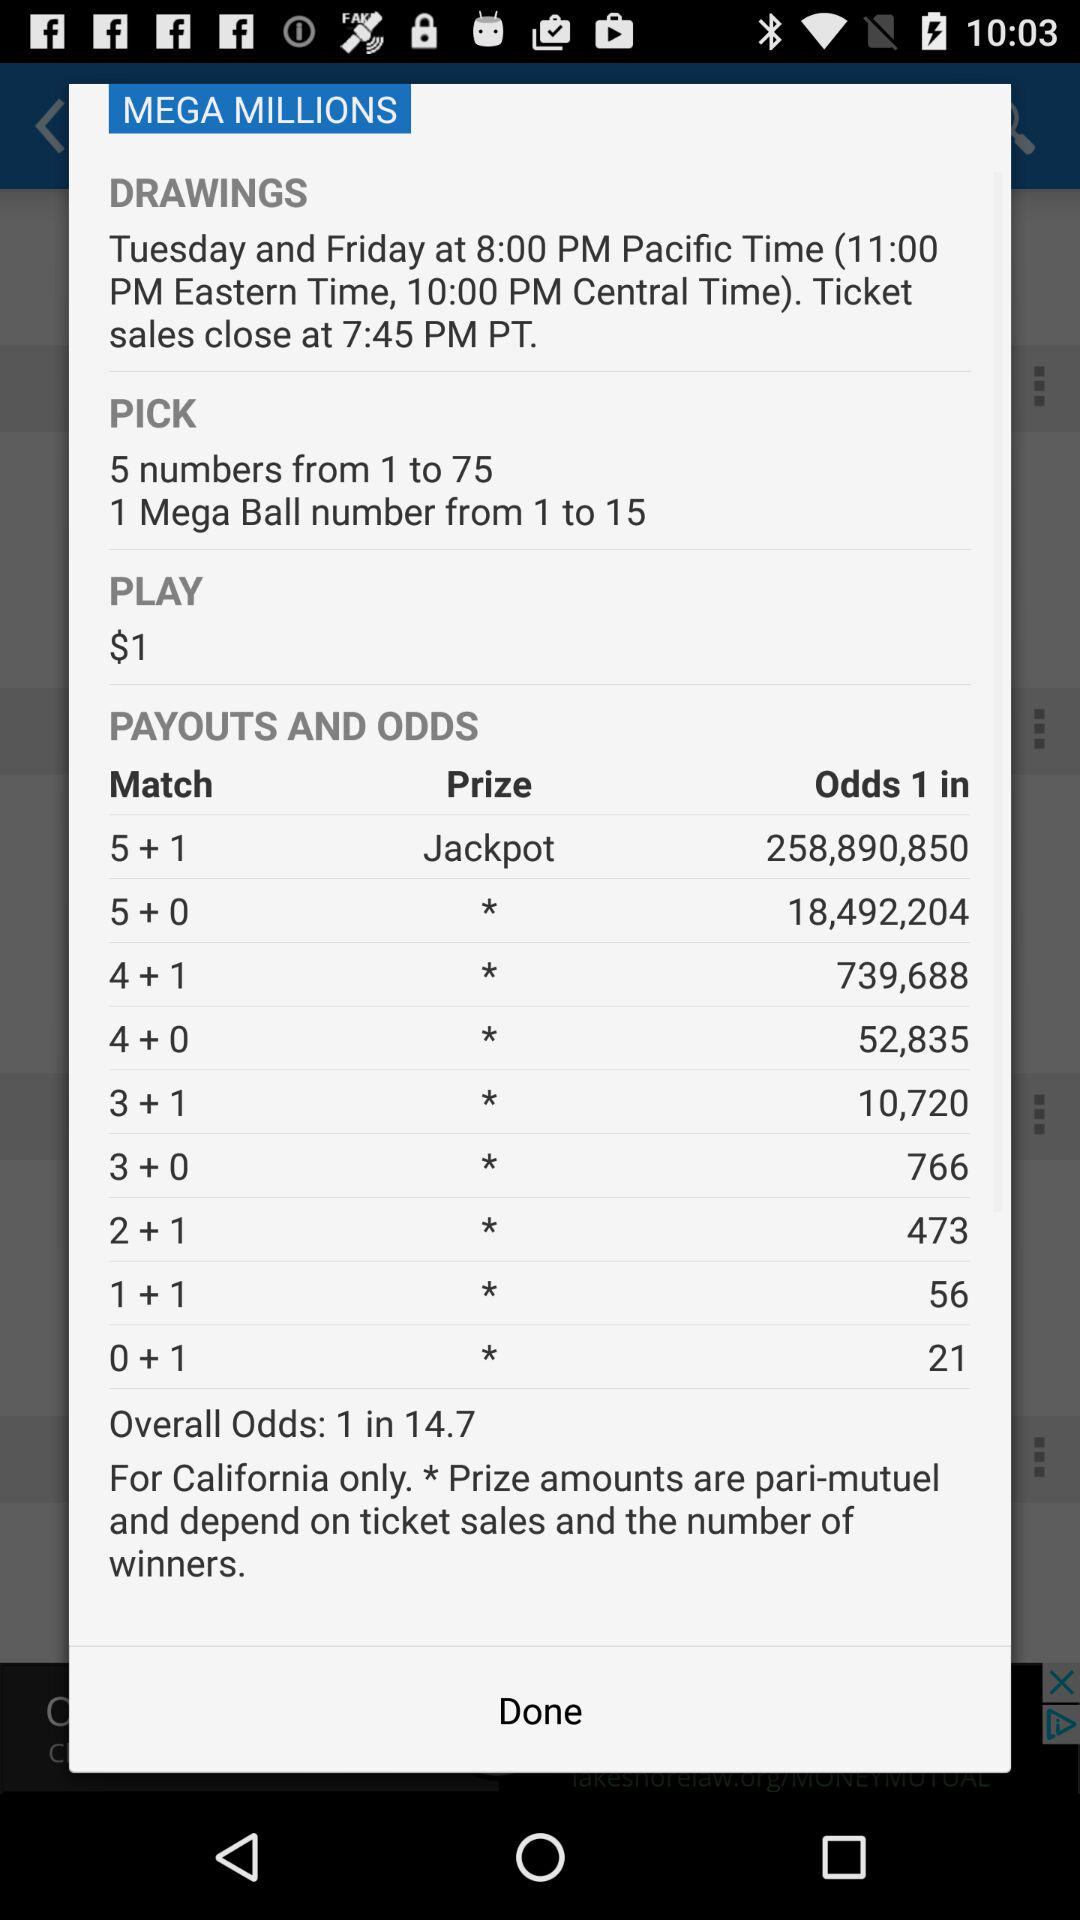How many numbers can be picked from 1 to 75? The number that can be picked from 1 to 75 is 5. 